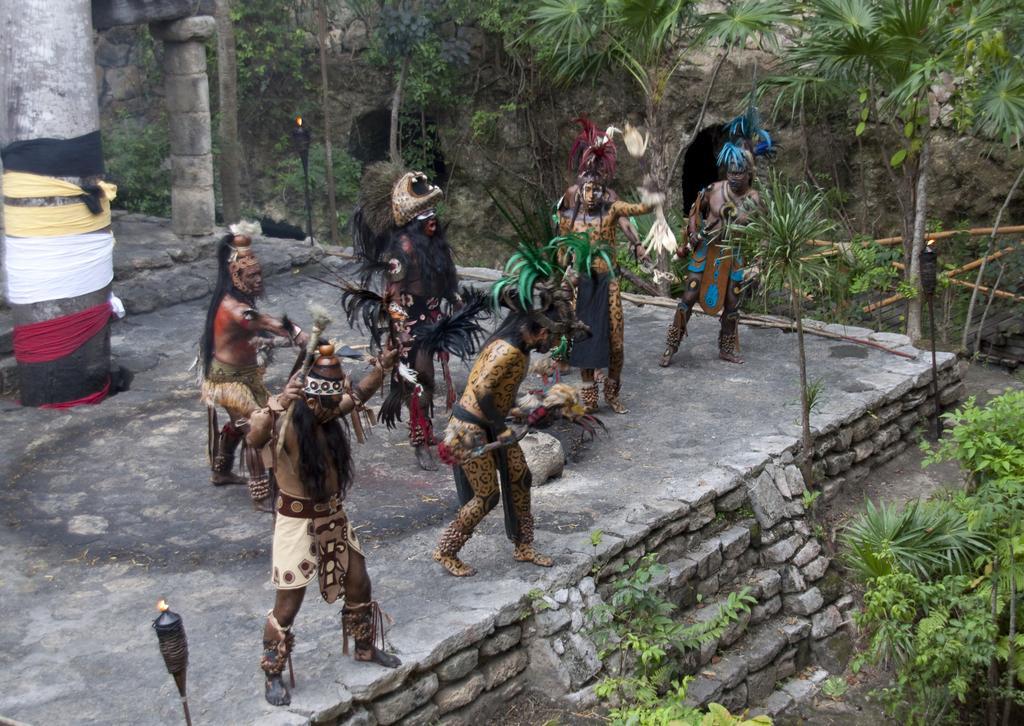Could you give a brief overview of what you see in this image? In this image we can see the tribal people and they are holding the wooden sticks in their hands. Here we can see the clothes of different colors on the pillar which is on the left side. Here we can see the trees and plants. 